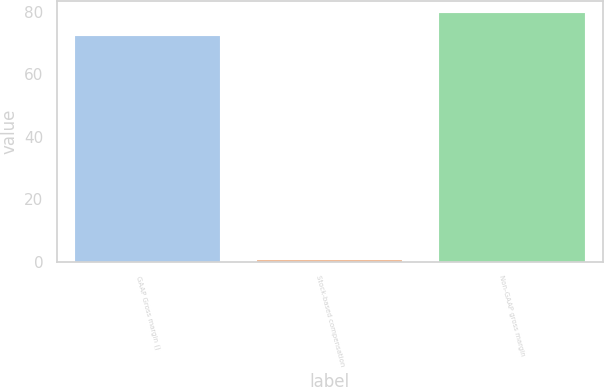Convert chart to OTSL. <chart><loc_0><loc_0><loc_500><loc_500><bar_chart><fcel>GAAP Gross margin ()<fcel>Stock-based compensation<fcel>Non-GAAP gross margin<nl><fcel>72.2<fcel>0.4<fcel>79.42<nl></chart> 